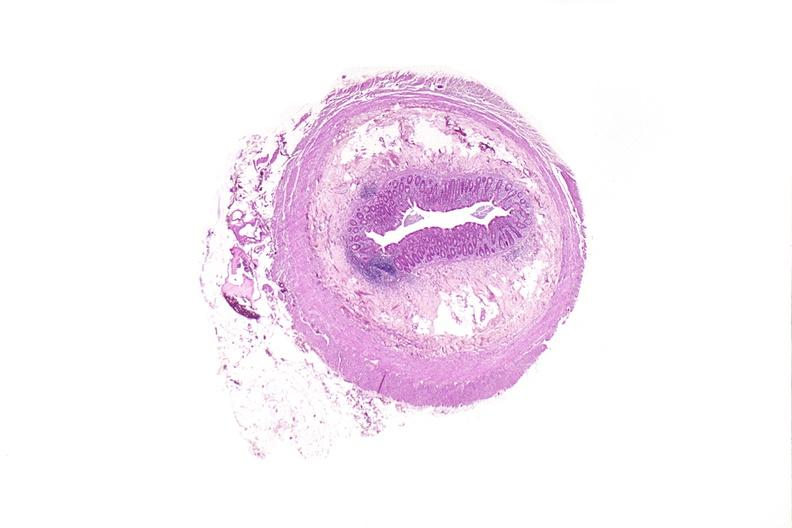where is this from?
Answer the question using a single word or phrase. Gastrointestinal system 